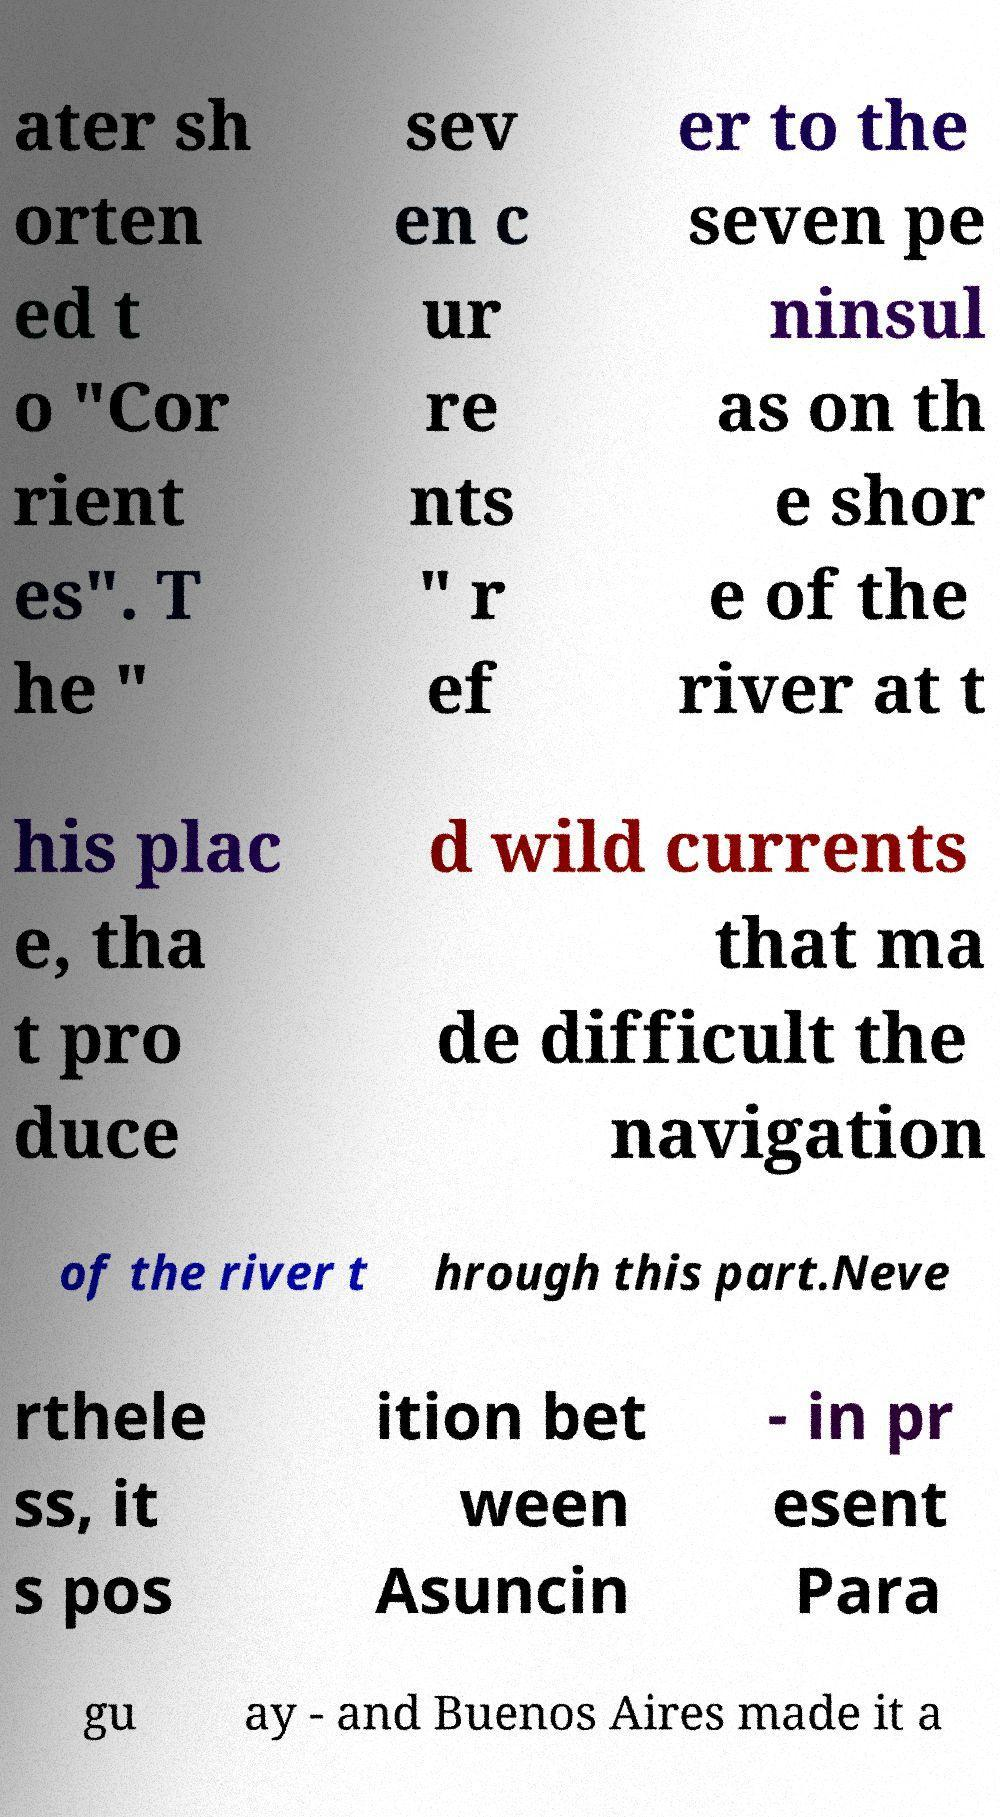Please identify and transcribe the text found in this image. ater sh orten ed t o "Cor rient es". T he " sev en c ur re nts " r ef er to the seven pe ninsul as on th e shor e of the river at t his plac e, tha t pro duce d wild currents that ma de difficult the navigation of the river t hrough this part.Neve rthele ss, it s pos ition bet ween Asuncin - in pr esent Para gu ay - and Buenos Aires made it a 